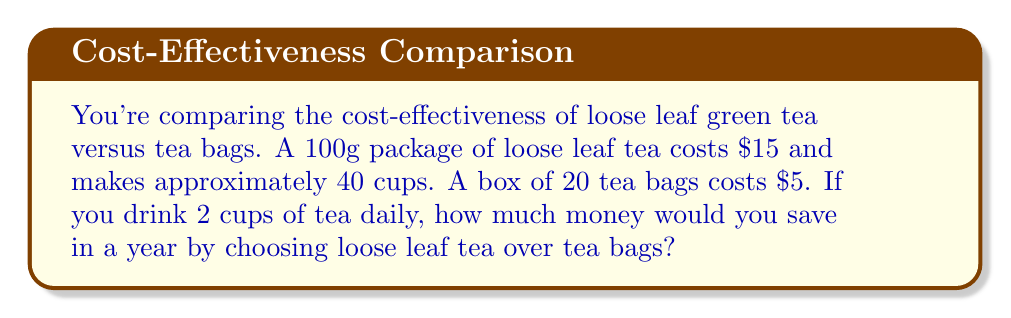Teach me how to tackle this problem. Let's approach this step-by-step:

1. Calculate the cost per cup for loose leaf tea:
   $\frac{\text{Cost of package}}{\text{Number of cups}} = \frac{\$15}{40} = \$0.375$ per cup

2. Calculate the cost per cup for tea bags:
   $\frac{\text{Cost of box}}{\text{Number of tea bags}} = \frac{\$5}{20} = \$0.25$ per cup

3. Calculate the number of cups consumed in a year:
   $2 \text{ cups per day} \times 365 \text{ days} = 730 \text{ cups per year}$

4. Calculate the annual cost for loose leaf tea:
   $730 \text{ cups} \times \$0.375 \text{ per cup} = \$273.75$

5. Calculate the annual cost for tea bags:
   $730 \text{ cups} \times \$0.25 \text{ per cup} = \$182.50$

6. Calculate the difference in cost:
   $\$273.75 - \$182.50 = -\$91.25$

The negative result indicates that loose leaf tea is actually more expensive in this scenario.

Therefore, you would not save money by choosing loose leaf tea. Instead, you would spend an additional $91.25 per year using loose leaf tea compared to tea bags.
Answer: $-\$91.25$ (additional cost for loose leaf tea) 